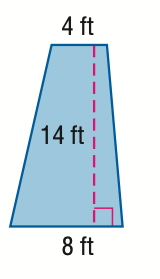Question: Find the area of the trapezoid.
Choices:
A. 28
B. 42
C. 84
D. 168
Answer with the letter. Answer: C 